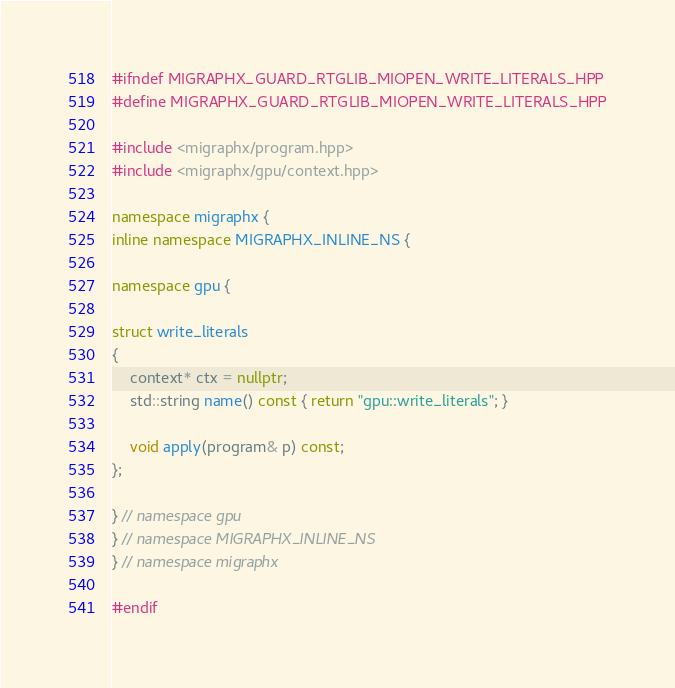<code> <loc_0><loc_0><loc_500><loc_500><_C++_>#ifndef MIGRAPHX_GUARD_RTGLIB_MIOPEN_WRITE_LITERALS_HPP
#define MIGRAPHX_GUARD_RTGLIB_MIOPEN_WRITE_LITERALS_HPP

#include <migraphx/program.hpp>
#include <migraphx/gpu/context.hpp>

namespace migraphx {
inline namespace MIGRAPHX_INLINE_NS {

namespace gpu {

struct write_literals
{
    context* ctx = nullptr;
    std::string name() const { return "gpu::write_literals"; }

    void apply(program& p) const;
};

} // namespace gpu
} // namespace MIGRAPHX_INLINE_NS
} // namespace migraphx

#endif
</code> 